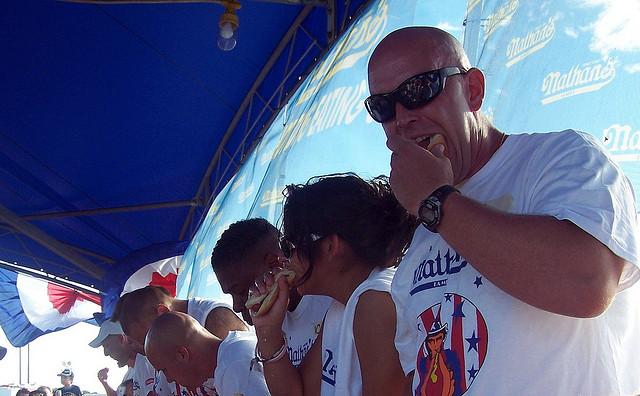What is the company name on their shirts?
Answer briefly. Nathan's. Is someone wearing sunglasses?
Concise answer only. Yes. What food item are the people consuming?
Short answer required. Hot dogs. 